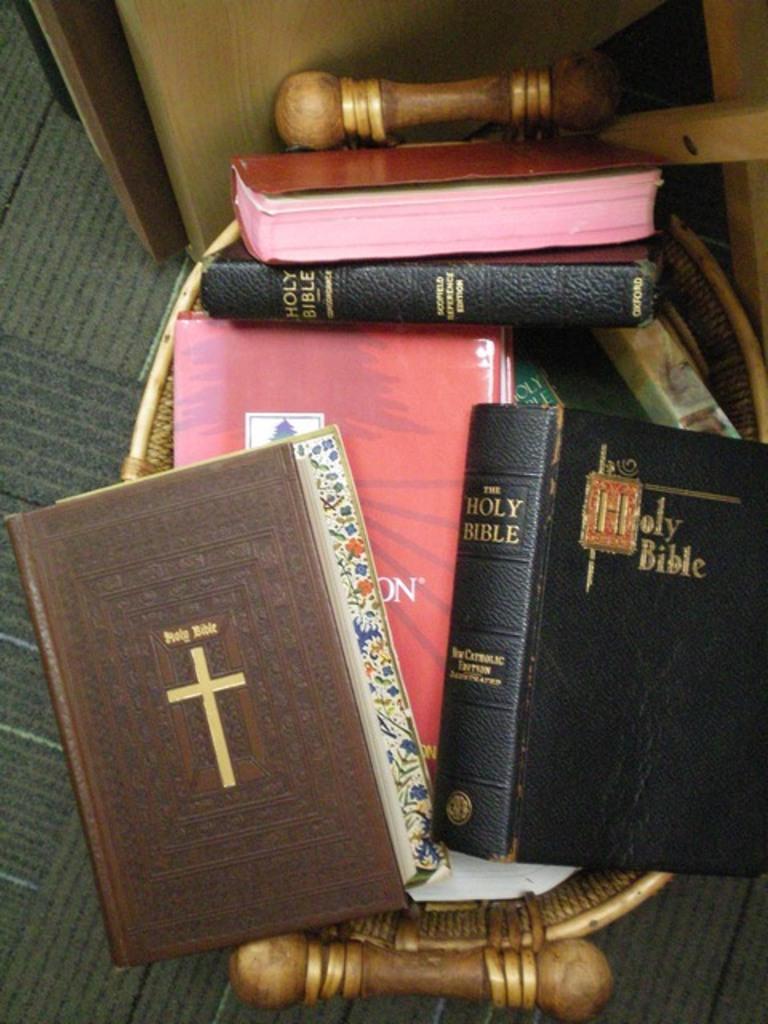Is that a camera?
Your response must be concise. No. 